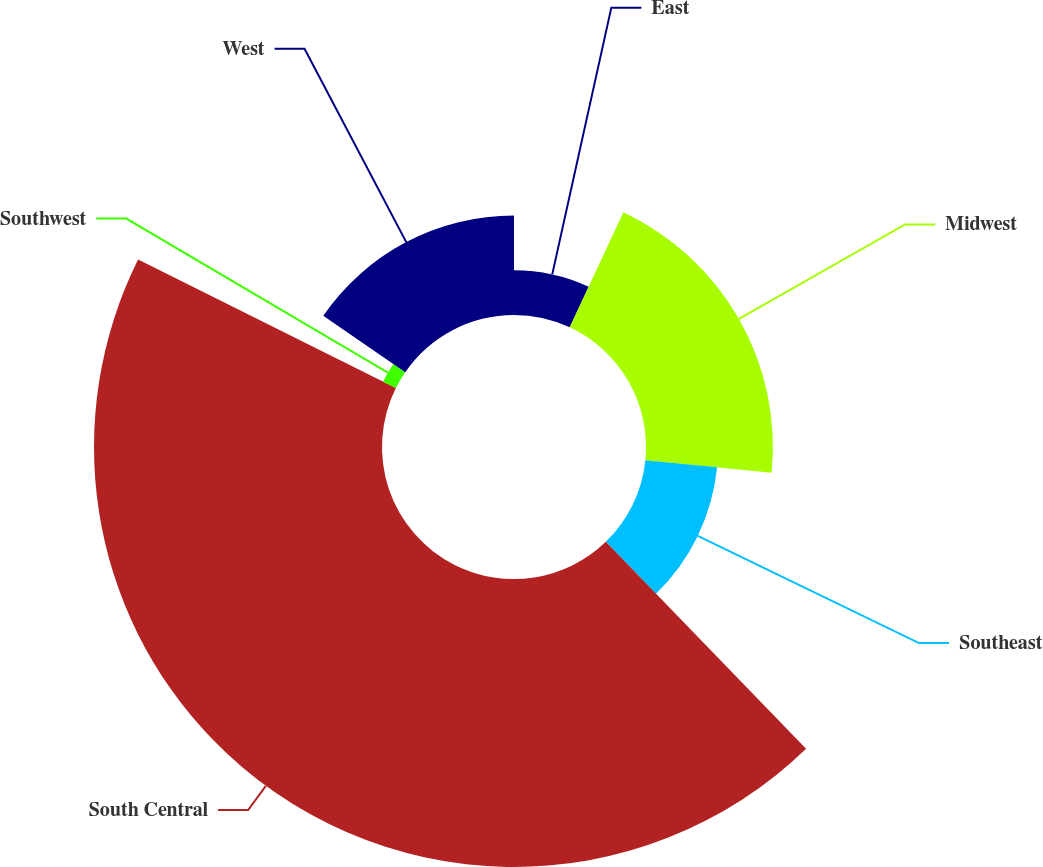<chart> <loc_0><loc_0><loc_500><loc_500><pie_chart><fcel>East<fcel>Midwest<fcel>Southeast<fcel>South Central<fcel>Southwest<fcel>West<nl><fcel>6.94%<fcel>19.65%<fcel>11.17%<fcel>44.6%<fcel>2.23%<fcel>15.41%<nl></chart> 